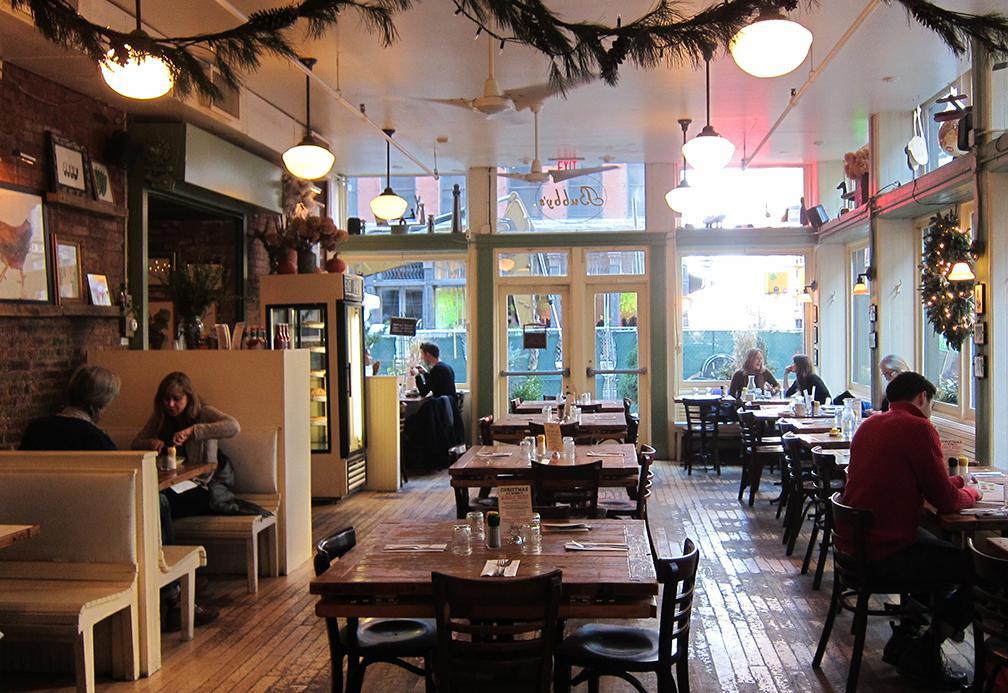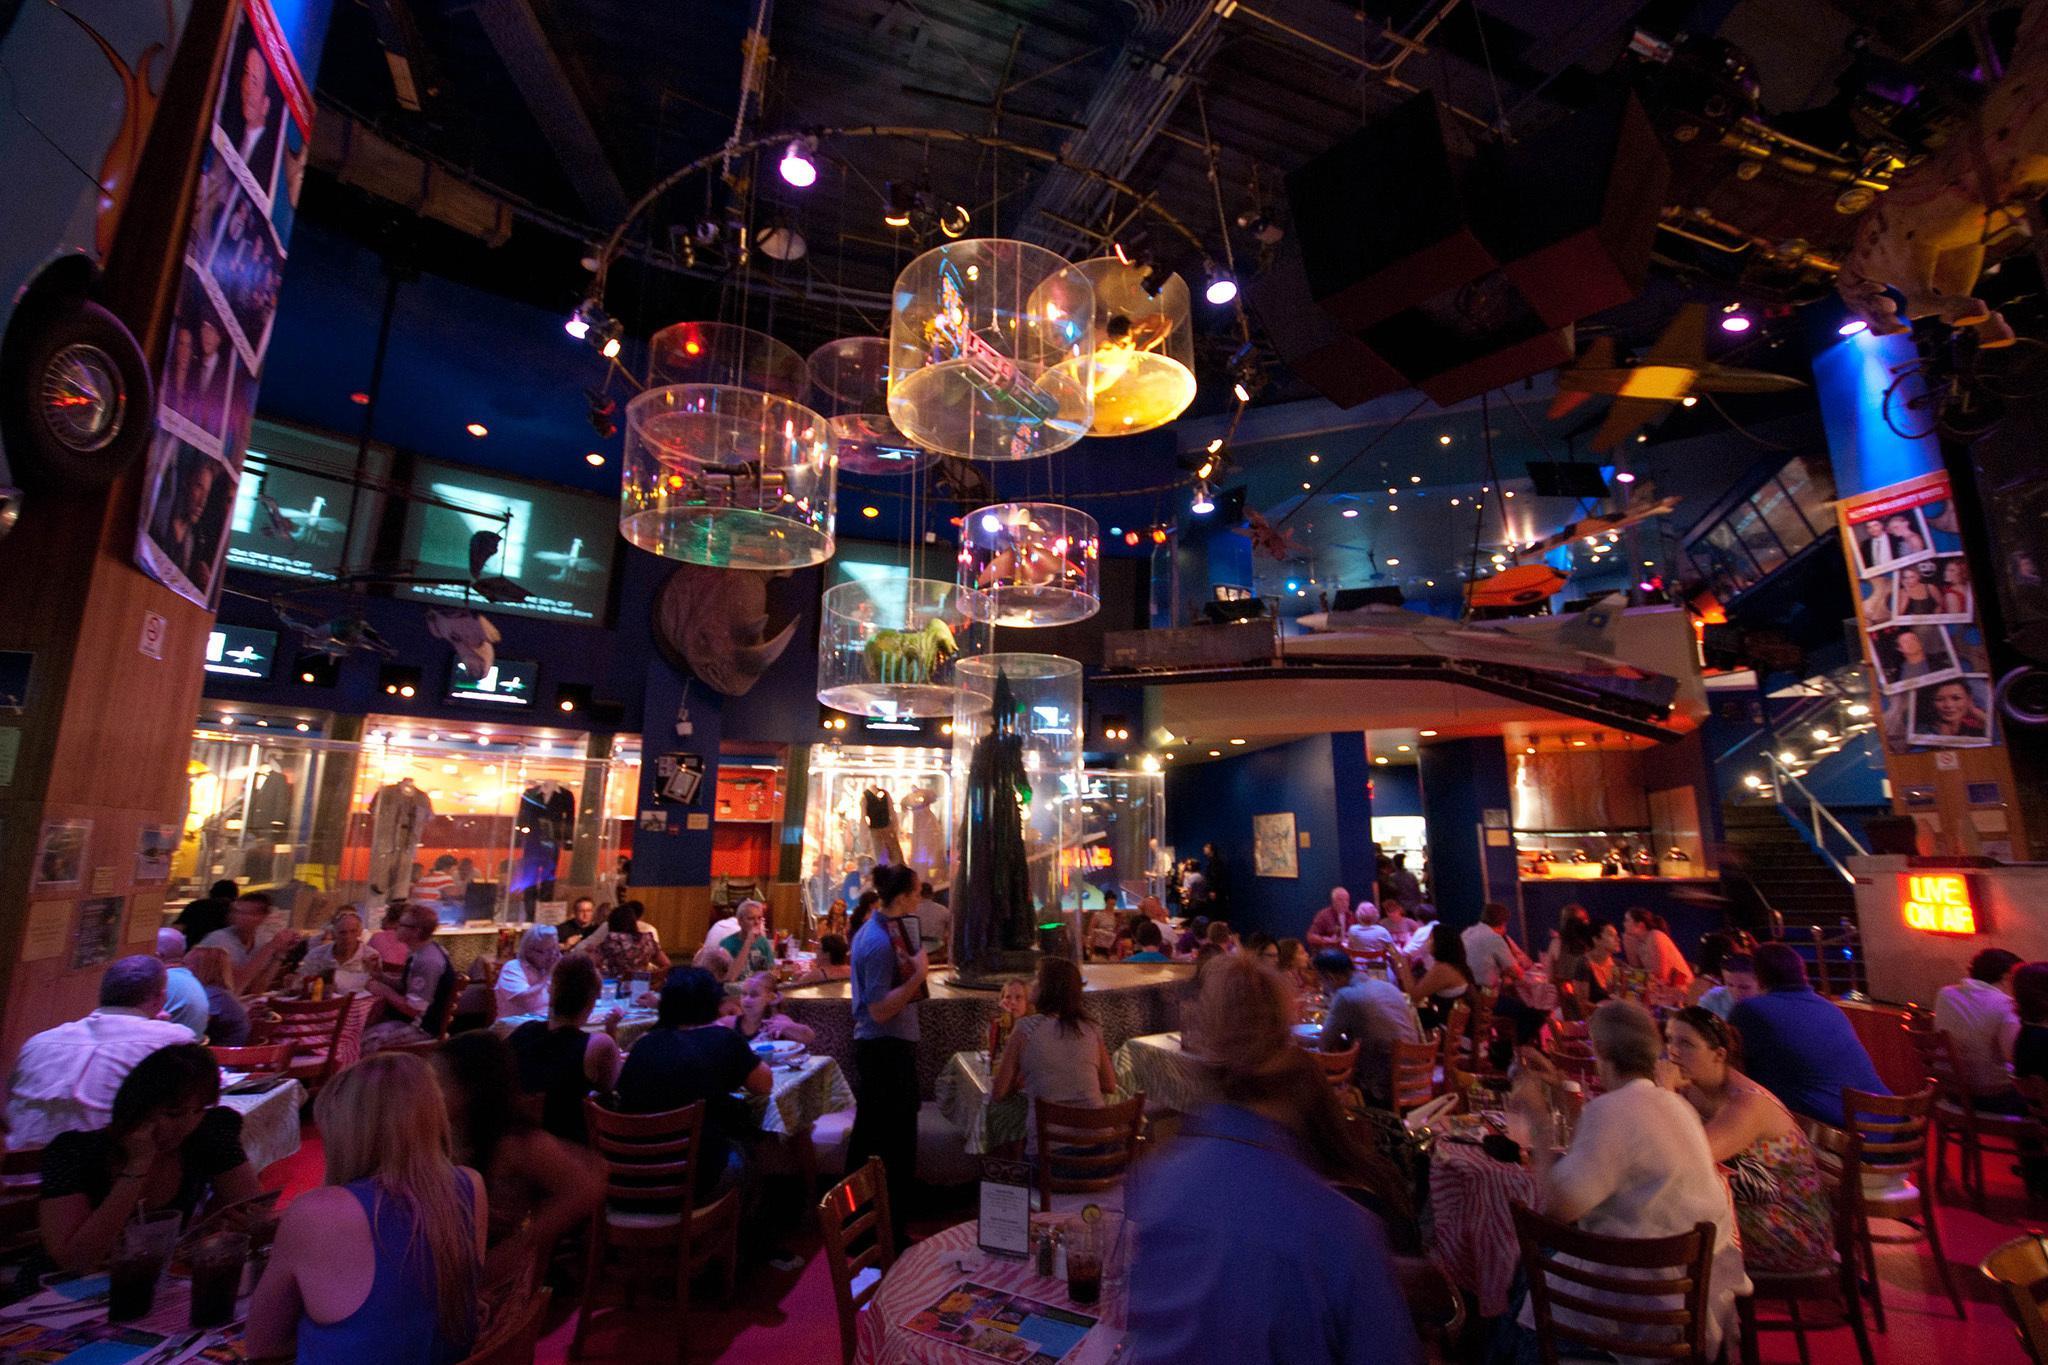The first image is the image on the left, the second image is the image on the right. For the images displayed, is the sentence "There are two empty cafes with no more than one person in the whole image." factually correct? Answer yes or no. No. The first image is the image on the left, the second image is the image on the right. For the images displayed, is the sentence "There are lights hanging from the ceiling in both images." factually correct? Answer yes or no. Yes. 